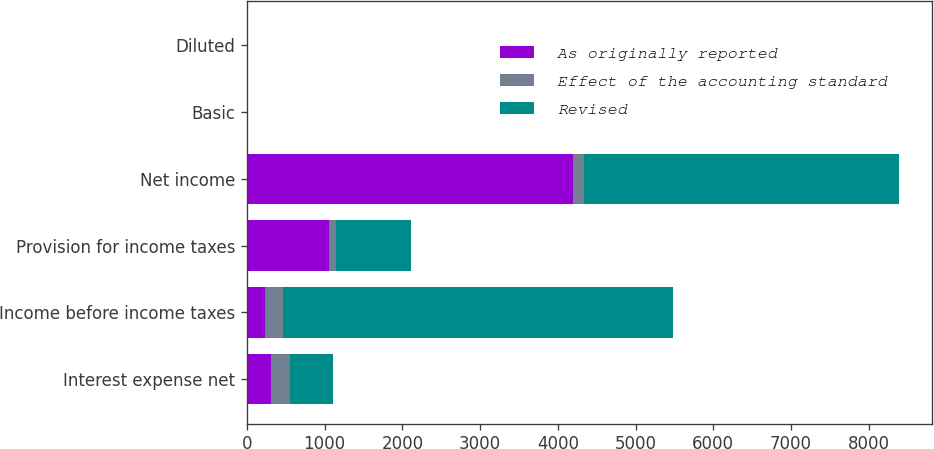Convert chart to OTSL. <chart><loc_0><loc_0><loc_500><loc_500><stacked_bar_chart><ecel><fcel>Interest expense net<fcel>Income before income taxes<fcel>Provision for income taxes<fcel>Net income<fcel>Basic<fcel>Diluted<nl><fcel>As originally reported<fcel>316<fcel>235<fcel>1054<fcel>4196<fcel>3.92<fcel>3.9<nl><fcel>Effect of the accounting standard<fcel>235<fcel>235<fcel>91<fcel>144<fcel>0.13<fcel>0.13<nl><fcel>Revised<fcel>551<fcel>5015<fcel>963<fcel>4052<fcel>3.79<fcel>3.77<nl></chart> 